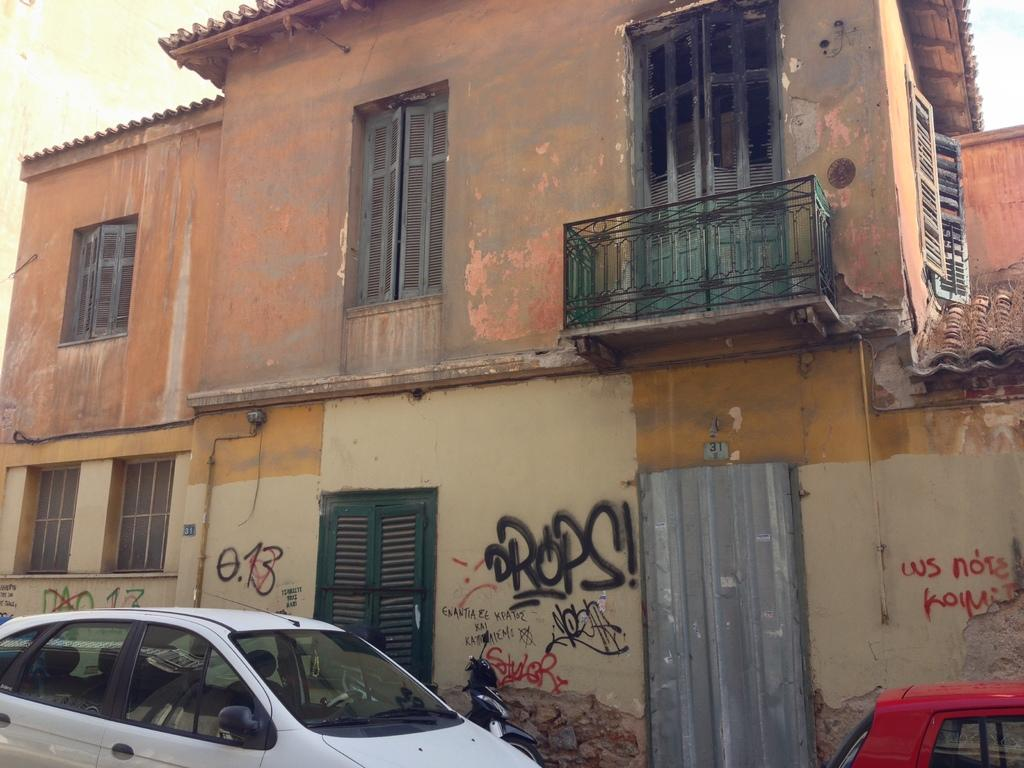What type of structure is visible in the image? There is a building in the image. What else can be seen at the bottom of the image? There are vehicles at the bottom of the image. Can you tell me how many firemen are present in the image? There is no indication of firemen or any emergency personnel in the image. 